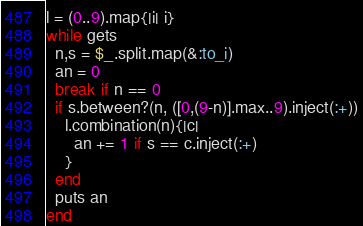<code> <loc_0><loc_0><loc_500><loc_500><_Ruby_>l = (0..9).map{|i| i}
while gets
  n,s = $_.split.map(&:to_i)
  an = 0
  break if n == 0
  if s.between?(n, ([0,(9-n)].max..9).inject(:+))
    l.combination(n){|c|
      an += 1 if s == c.inject(:+)
    }
  end
  puts an
end</code> 